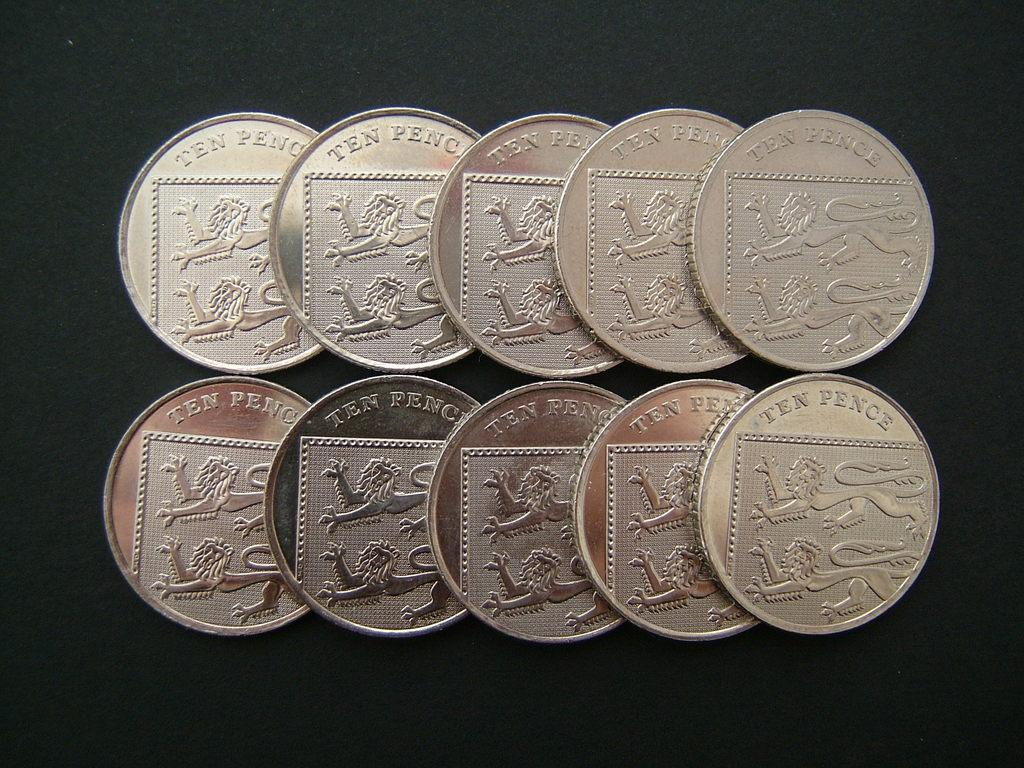<image>
Offer a succinct explanation of the picture presented. ten, ten pence coins are laying in two rows on a black background 